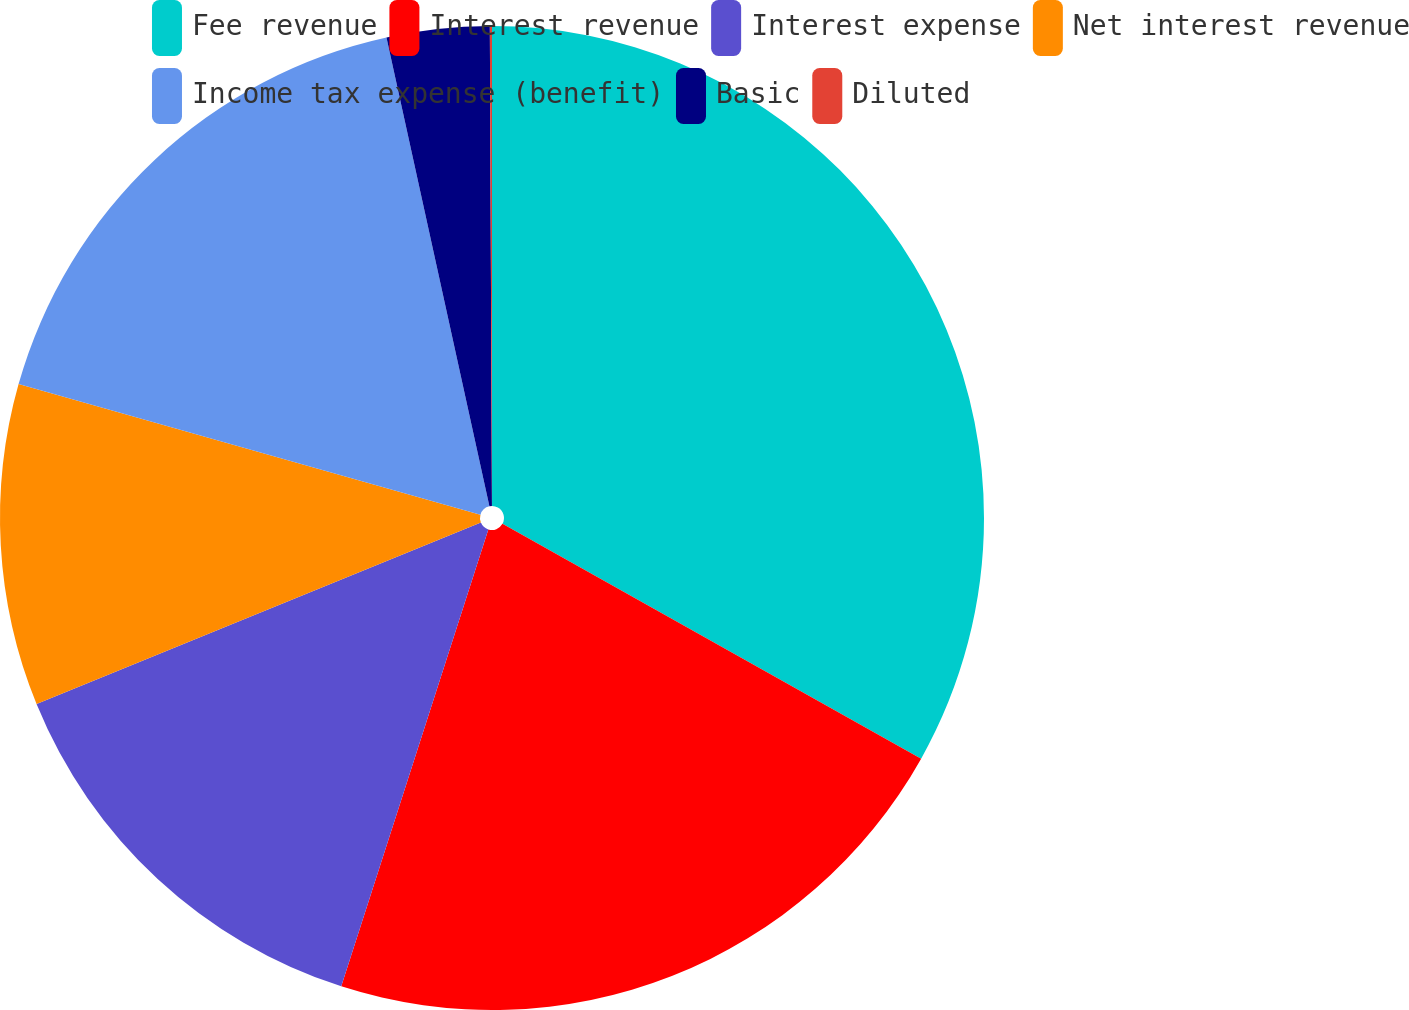Convert chart to OTSL. <chart><loc_0><loc_0><loc_500><loc_500><pie_chart><fcel>Fee revenue<fcel>Interest revenue<fcel>Interest expense<fcel>Net interest revenue<fcel>Income tax expense (benefit)<fcel>Basic<fcel>Diluted<nl><fcel>33.13%<fcel>21.82%<fcel>13.87%<fcel>10.56%<fcel>17.17%<fcel>3.37%<fcel>0.07%<nl></chart> 